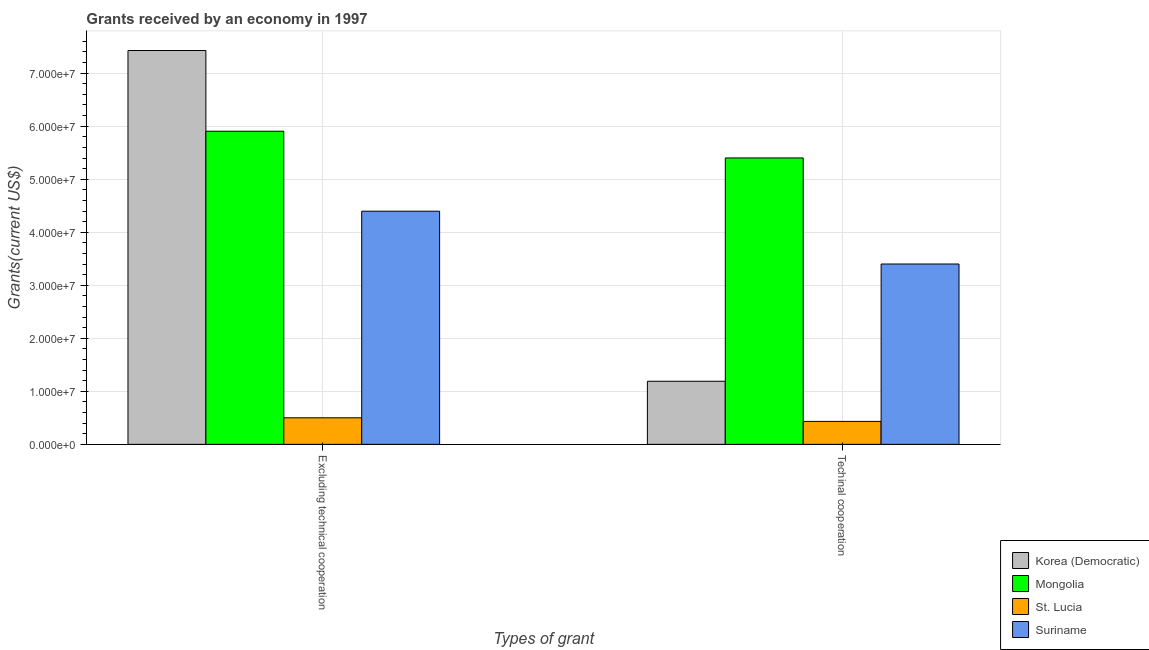Are the number of bars per tick equal to the number of legend labels?
Your response must be concise. Yes. Are the number of bars on each tick of the X-axis equal?
Your response must be concise. Yes. How many bars are there on the 1st tick from the left?
Make the answer very short. 4. How many bars are there on the 2nd tick from the right?
Provide a succinct answer. 4. What is the label of the 1st group of bars from the left?
Keep it short and to the point. Excluding technical cooperation. What is the amount of grants received(including technical cooperation) in Korea (Democratic)?
Ensure brevity in your answer.  1.19e+07. Across all countries, what is the maximum amount of grants received(including technical cooperation)?
Keep it short and to the point. 5.40e+07. Across all countries, what is the minimum amount of grants received(including technical cooperation)?
Your response must be concise. 4.33e+06. In which country was the amount of grants received(excluding technical cooperation) maximum?
Offer a terse response. Korea (Democratic). In which country was the amount of grants received(excluding technical cooperation) minimum?
Give a very brief answer. St. Lucia. What is the total amount of grants received(including technical cooperation) in the graph?
Give a very brief answer. 1.04e+08. What is the difference between the amount of grants received(including technical cooperation) in St. Lucia and that in Mongolia?
Keep it short and to the point. -4.97e+07. What is the difference between the amount of grants received(excluding technical cooperation) in Korea (Democratic) and the amount of grants received(including technical cooperation) in Mongolia?
Provide a succinct answer. 2.03e+07. What is the average amount of grants received(excluding technical cooperation) per country?
Your response must be concise. 4.56e+07. What is the difference between the amount of grants received(excluding technical cooperation) and amount of grants received(including technical cooperation) in Suriname?
Your response must be concise. 9.96e+06. What is the ratio of the amount of grants received(excluding technical cooperation) in Suriname to that in Korea (Democratic)?
Provide a short and direct response. 0.59. In how many countries, is the amount of grants received(excluding technical cooperation) greater than the average amount of grants received(excluding technical cooperation) taken over all countries?
Make the answer very short. 2. What does the 4th bar from the left in Excluding technical cooperation represents?
Ensure brevity in your answer.  Suriname. What does the 3rd bar from the right in Techinal cooperation represents?
Offer a very short reply. Mongolia. Are all the bars in the graph horizontal?
Give a very brief answer. No. How many countries are there in the graph?
Give a very brief answer. 4. What is the difference between two consecutive major ticks on the Y-axis?
Make the answer very short. 1.00e+07. Are the values on the major ticks of Y-axis written in scientific E-notation?
Keep it short and to the point. Yes. Where does the legend appear in the graph?
Provide a short and direct response. Bottom right. What is the title of the graph?
Offer a terse response. Grants received by an economy in 1997. What is the label or title of the X-axis?
Offer a very short reply. Types of grant. What is the label or title of the Y-axis?
Your answer should be compact. Grants(current US$). What is the Grants(current US$) of Korea (Democratic) in Excluding technical cooperation?
Your answer should be very brief. 7.43e+07. What is the Grants(current US$) in Mongolia in Excluding technical cooperation?
Ensure brevity in your answer.  5.90e+07. What is the Grants(current US$) of St. Lucia in Excluding technical cooperation?
Your response must be concise. 5.01e+06. What is the Grants(current US$) of Suriname in Excluding technical cooperation?
Offer a very short reply. 4.40e+07. What is the Grants(current US$) of Korea (Democratic) in Techinal cooperation?
Keep it short and to the point. 1.19e+07. What is the Grants(current US$) of Mongolia in Techinal cooperation?
Your response must be concise. 5.40e+07. What is the Grants(current US$) of St. Lucia in Techinal cooperation?
Provide a succinct answer. 4.33e+06. What is the Grants(current US$) of Suriname in Techinal cooperation?
Provide a short and direct response. 3.40e+07. Across all Types of grant, what is the maximum Grants(current US$) in Korea (Democratic)?
Keep it short and to the point. 7.43e+07. Across all Types of grant, what is the maximum Grants(current US$) in Mongolia?
Give a very brief answer. 5.90e+07. Across all Types of grant, what is the maximum Grants(current US$) of St. Lucia?
Ensure brevity in your answer.  5.01e+06. Across all Types of grant, what is the maximum Grants(current US$) in Suriname?
Offer a terse response. 4.40e+07. Across all Types of grant, what is the minimum Grants(current US$) of Korea (Democratic)?
Ensure brevity in your answer.  1.19e+07. Across all Types of grant, what is the minimum Grants(current US$) in Mongolia?
Your response must be concise. 5.40e+07. Across all Types of grant, what is the minimum Grants(current US$) in St. Lucia?
Provide a short and direct response. 4.33e+06. Across all Types of grant, what is the minimum Grants(current US$) in Suriname?
Provide a succinct answer. 3.40e+07. What is the total Grants(current US$) in Korea (Democratic) in the graph?
Ensure brevity in your answer.  8.62e+07. What is the total Grants(current US$) of Mongolia in the graph?
Offer a terse response. 1.13e+08. What is the total Grants(current US$) in St. Lucia in the graph?
Your response must be concise. 9.34e+06. What is the total Grants(current US$) of Suriname in the graph?
Keep it short and to the point. 7.80e+07. What is the difference between the Grants(current US$) in Korea (Democratic) in Excluding technical cooperation and that in Techinal cooperation?
Make the answer very short. 6.24e+07. What is the difference between the Grants(current US$) of Mongolia in Excluding technical cooperation and that in Techinal cooperation?
Your answer should be compact. 5.04e+06. What is the difference between the Grants(current US$) of St. Lucia in Excluding technical cooperation and that in Techinal cooperation?
Keep it short and to the point. 6.80e+05. What is the difference between the Grants(current US$) of Suriname in Excluding technical cooperation and that in Techinal cooperation?
Provide a succinct answer. 9.96e+06. What is the difference between the Grants(current US$) of Korea (Democratic) in Excluding technical cooperation and the Grants(current US$) of Mongolia in Techinal cooperation?
Give a very brief answer. 2.03e+07. What is the difference between the Grants(current US$) of Korea (Democratic) in Excluding technical cooperation and the Grants(current US$) of St. Lucia in Techinal cooperation?
Your answer should be compact. 6.99e+07. What is the difference between the Grants(current US$) in Korea (Democratic) in Excluding technical cooperation and the Grants(current US$) in Suriname in Techinal cooperation?
Make the answer very short. 4.03e+07. What is the difference between the Grants(current US$) of Mongolia in Excluding technical cooperation and the Grants(current US$) of St. Lucia in Techinal cooperation?
Your response must be concise. 5.47e+07. What is the difference between the Grants(current US$) in Mongolia in Excluding technical cooperation and the Grants(current US$) in Suriname in Techinal cooperation?
Provide a short and direct response. 2.50e+07. What is the difference between the Grants(current US$) of St. Lucia in Excluding technical cooperation and the Grants(current US$) of Suriname in Techinal cooperation?
Your response must be concise. -2.90e+07. What is the average Grants(current US$) of Korea (Democratic) per Types of grant?
Give a very brief answer. 4.31e+07. What is the average Grants(current US$) in Mongolia per Types of grant?
Give a very brief answer. 5.65e+07. What is the average Grants(current US$) in St. Lucia per Types of grant?
Give a very brief answer. 4.67e+06. What is the average Grants(current US$) in Suriname per Types of grant?
Your answer should be compact. 3.90e+07. What is the difference between the Grants(current US$) in Korea (Democratic) and Grants(current US$) in Mongolia in Excluding technical cooperation?
Provide a succinct answer. 1.52e+07. What is the difference between the Grants(current US$) in Korea (Democratic) and Grants(current US$) in St. Lucia in Excluding technical cooperation?
Keep it short and to the point. 6.93e+07. What is the difference between the Grants(current US$) of Korea (Democratic) and Grants(current US$) of Suriname in Excluding technical cooperation?
Keep it short and to the point. 3.03e+07. What is the difference between the Grants(current US$) in Mongolia and Grants(current US$) in St. Lucia in Excluding technical cooperation?
Keep it short and to the point. 5.40e+07. What is the difference between the Grants(current US$) in Mongolia and Grants(current US$) in Suriname in Excluding technical cooperation?
Keep it short and to the point. 1.51e+07. What is the difference between the Grants(current US$) in St. Lucia and Grants(current US$) in Suriname in Excluding technical cooperation?
Provide a short and direct response. -3.90e+07. What is the difference between the Grants(current US$) of Korea (Democratic) and Grants(current US$) of Mongolia in Techinal cooperation?
Ensure brevity in your answer.  -4.21e+07. What is the difference between the Grants(current US$) in Korea (Democratic) and Grants(current US$) in St. Lucia in Techinal cooperation?
Your answer should be compact. 7.57e+06. What is the difference between the Grants(current US$) in Korea (Democratic) and Grants(current US$) in Suriname in Techinal cooperation?
Ensure brevity in your answer.  -2.21e+07. What is the difference between the Grants(current US$) of Mongolia and Grants(current US$) of St. Lucia in Techinal cooperation?
Your response must be concise. 4.97e+07. What is the difference between the Grants(current US$) in Mongolia and Grants(current US$) in Suriname in Techinal cooperation?
Give a very brief answer. 2.00e+07. What is the difference between the Grants(current US$) in St. Lucia and Grants(current US$) in Suriname in Techinal cooperation?
Your answer should be very brief. -2.97e+07. What is the ratio of the Grants(current US$) of Korea (Democratic) in Excluding technical cooperation to that in Techinal cooperation?
Ensure brevity in your answer.  6.24. What is the ratio of the Grants(current US$) in Mongolia in Excluding technical cooperation to that in Techinal cooperation?
Your response must be concise. 1.09. What is the ratio of the Grants(current US$) of St. Lucia in Excluding technical cooperation to that in Techinal cooperation?
Make the answer very short. 1.16. What is the ratio of the Grants(current US$) of Suriname in Excluding technical cooperation to that in Techinal cooperation?
Make the answer very short. 1.29. What is the difference between the highest and the second highest Grants(current US$) in Korea (Democratic)?
Offer a very short reply. 6.24e+07. What is the difference between the highest and the second highest Grants(current US$) in Mongolia?
Your answer should be compact. 5.04e+06. What is the difference between the highest and the second highest Grants(current US$) in St. Lucia?
Make the answer very short. 6.80e+05. What is the difference between the highest and the second highest Grants(current US$) in Suriname?
Offer a terse response. 9.96e+06. What is the difference between the highest and the lowest Grants(current US$) of Korea (Democratic)?
Offer a very short reply. 6.24e+07. What is the difference between the highest and the lowest Grants(current US$) in Mongolia?
Your response must be concise. 5.04e+06. What is the difference between the highest and the lowest Grants(current US$) of St. Lucia?
Offer a very short reply. 6.80e+05. What is the difference between the highest and the lowest Grants(current US$) of Suriname?
Your response must be concise. 9.96e+06. 